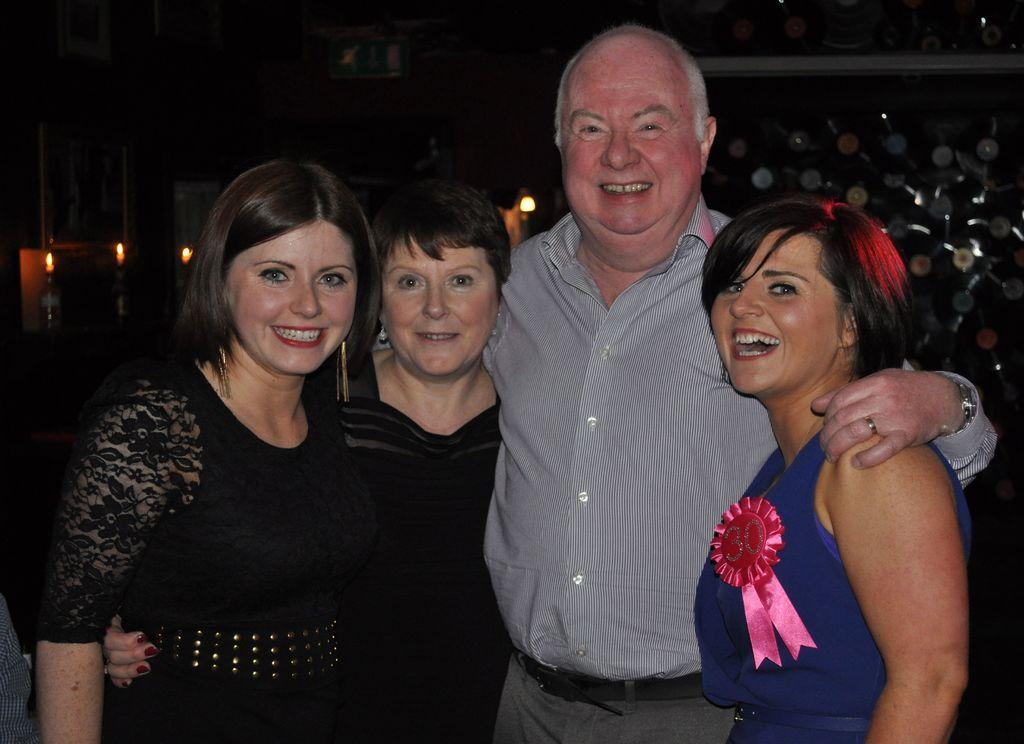What is happening in the image? There is a group of people standing in the image. What can be seen in addition to the people? There are candles visible in the image. Can you describe the objects on the backside of the image? Unfortunately, the provided facts do not give any information about the objects on the backside of the image. What type of needle is being used to express hate in the image? There is no needle or expression of hate present in the image. 